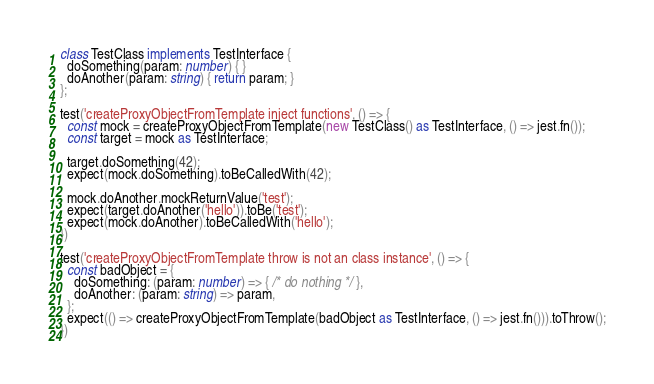Convert code to text. <code><loc_0><loc_0><loc_500><loc_500><_TypeScript_>class TestClass implements TestInterface {
  doSomething(param: number) { }
  doAnother(param: string) { return param; }
};

test('createProxyObjectFromTemplate inject functions', () => {
  const mock = createProxyObjectFromTemplate(new TestClass() as TestInterface, () => jest.fn());
  const target = mock as TestInterface;

  target.doSomething(42);
  expect(mock.doSomething).toBeCalledWith(42);

  mock.doAnother.mockReturnValue('test');
  expect(target.doAnother('hello')).toBe('test');
  expect(mock.doAnother).toBeCalledWith('hello');
})

test('createProxyObjectFromTemplate throw is not an class instance', () => {
  const badObject = {
    doSomething: (param: number) => { /* do nothing */ },
    doAnother: (param: string) => param,
  };
  expect(() => createProxyObjectFromTemplate(badObject as TestInterface, () => jest.fn())).toThrow();
})

</code> 